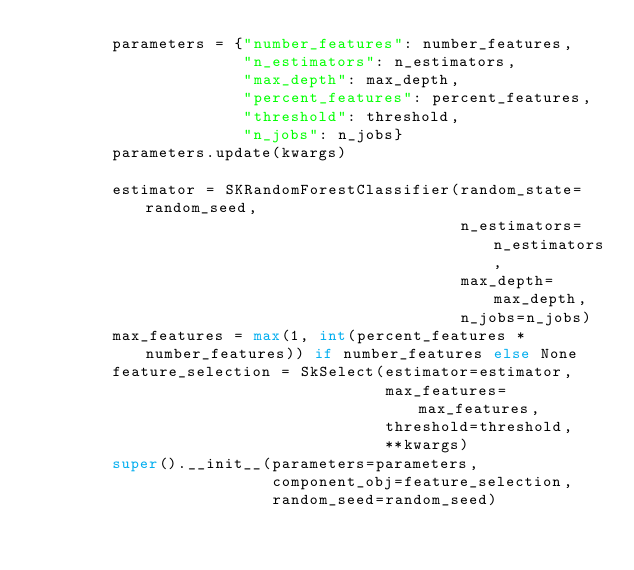Convert code to text. <code><loc_0><loc_0><loc_500><loc_500><_Python_>        parameters = {"number_features": number_features,
                      "n_estimators": n_estimators,
                      "max_depth": max_depth,
                      "percent_features": percent_features,
                      "threshold": threshold,
                      "n_jobs": n_jobs}
        parameters.update(kwargs)

        estimator = SKRandomForestClassifier(random_state=random_seed,
                                             n_estimators=n_estimators,
                                             max_depth=max_depth,
                                             n_jobs=n_jobs)
        max_features = max(1, int(percent_features * number_features)) if number_features else None
        feature_selection = SkSelect(estimator=estimator,
                                     max_features=max_features,
                                     threshold=threshold,
                                     **kwargs)
        super().__init__(parameters=parameters,
                         component_obj=feature_selection,
                         random_seed=random_seed)
</code> 